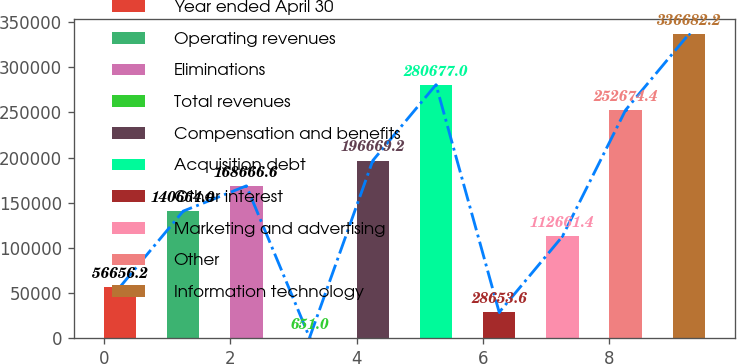Convert chart to OTSL. <chart><loc_0><loc_0><loc_500><loc_500><bar_chart><fcel>Year ended April 30<fcel>Operating revenues<fcel>Eliminations<fcel>Total revenues<fcel>Compensation and benefits<fcel>Acquisition debt<fcel>Other interest<fcel>Marketing and advertising<fcel>Other<fcel>Information technology<nl><fcel>56656.2<fcel>140664<fcel>168667<fcel>651<fcel>196669<fcel>280677<fcel>28653.6<fcel>112661<fcel>252674<fcel>336682<nl></chart> 